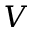<formula> <loc_0><loc_0><loc_500><loc_500>V</formula> 